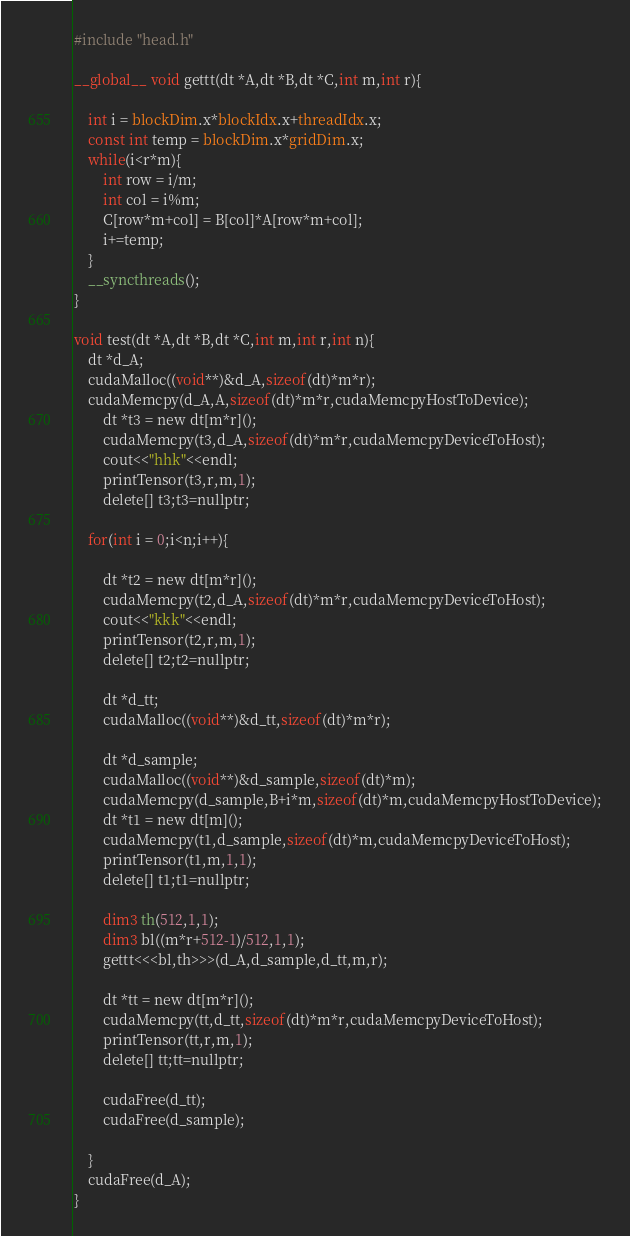<code> <loc_0><loc_0><loc_500><loc_500><_Cuda_>#include "head.h"

__global__ void gettt(dt *A,dt *B,dt *C,int m,int r){
	
	int i = blockDim.x*blockIdx.x+threadIdx.x;
	const int temp = blockDim.x*gridDim.x;
	while(i<r*m){
		int row = i/m;
		int col = i%m;
		C[row*m+col] = B[col]*A[row*m+col];
		i+=temp;
	}
	__syncthreads();
}

void test(dt *A,dt *B,dt *C,int m,int r,int n){
	dt *d_A;
	cudaMalloc((void**)&d_A,sizeof(dt)*m*r);
	cudaMemcpy(d_A,A,sizeof(dt)*m*r,cudaMemcpyHostToDevice);
		dt *t3 = new dt[m*r]();
		cudaMemcpy(t3,d_A,sizeof(dt)*m*r,cudaMemcpyDeviceToHost);
		cout<<"hhk"<<endl;
		printTensor(t3,r,m,1);
		delete[] t3;t3=nullptr;

	for(int i = 0;i<n;i++){
	
		dt *t2 = new dt[m*r]();
		cudaMemcpy(t2,d_A,sizeof(dt)*m*r,cudaMemcpyDeviceToHost);
		cout<<"kkk"<<endl;
		printTensor(t2,r,m,1);
		delete[] t2;t2=nullptr;

		dt *d_tt;
		cudaMalloc((void**)&d_tt,sizeof(dt)*m*r);
		
		dt *d_sample;
		cudaMalloc((void**)&d_sample,sizeof(dt)*m);
		cudaMemcpy(d_sample,B+i*m,sizeof(dt)*m,cudaMemcpyHostToDevice);
		dt *t1 = new dt[m]();
		cudaMemcpy(t1,d_sample,sizeof(dt)*m,cudaMemcpyDeviceToHost);
		printTensor(t1,m,1,1);
		delete[] t1;t1=nullptr;

		dim3 th(512,1,1);
		dim3 bl((m*r+512-1)/512,1,1);
		gettt<<<bl,th>>>(d_A,d_sample,d_tt,m,r);

		dt *tt = new dt[m*r]();
		cudaMemcpy(tt,d_tt,sizeof(dt)*m*r,cudaMemcpyDeviceToHost);
		printTensor(tt,r,m,1);
		delete[] tt;tt=nullptr;

		cudaFree(d_tt);
		cudaFree(d_sample);

	}
	cudaFree(d_A);
}
</code> 